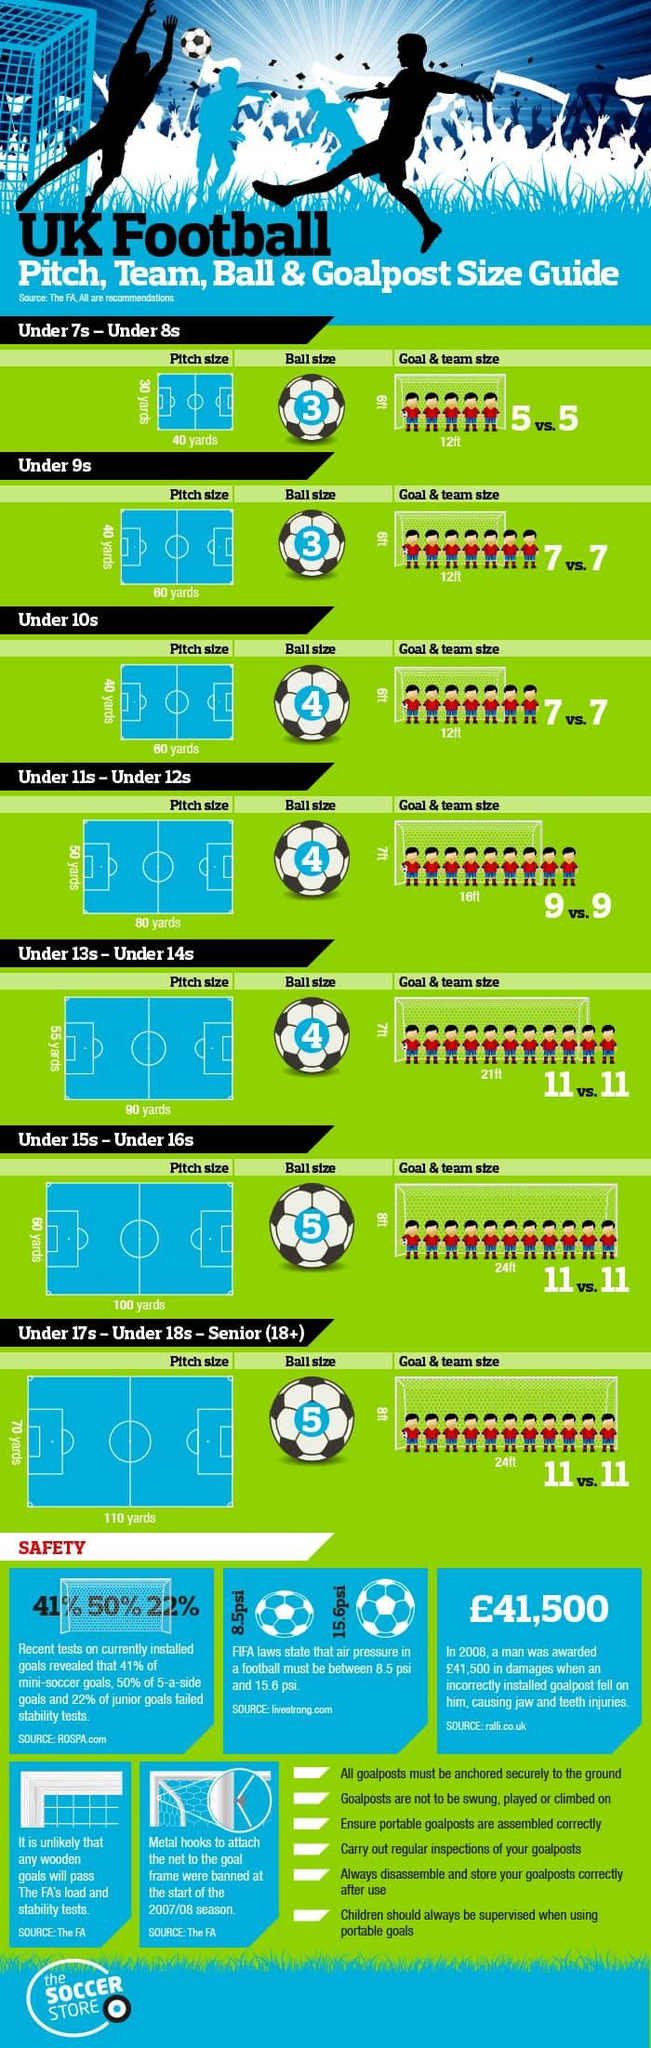Specify some key components in this picture. The recommended pitch length for a team of 11 is 110 yards. The goal length required for a 100 yard pitch is 24 feet. The team recommended a pitch size of 40 x 60 yards and a ball size of 4 for players under the age of 10. The Under 9s and Under 10s teams utilize a pitch that measures 40 x 60 yards in size. Ball size 3 is used by Under 7s, Under 8s, Under 9s, and others. 